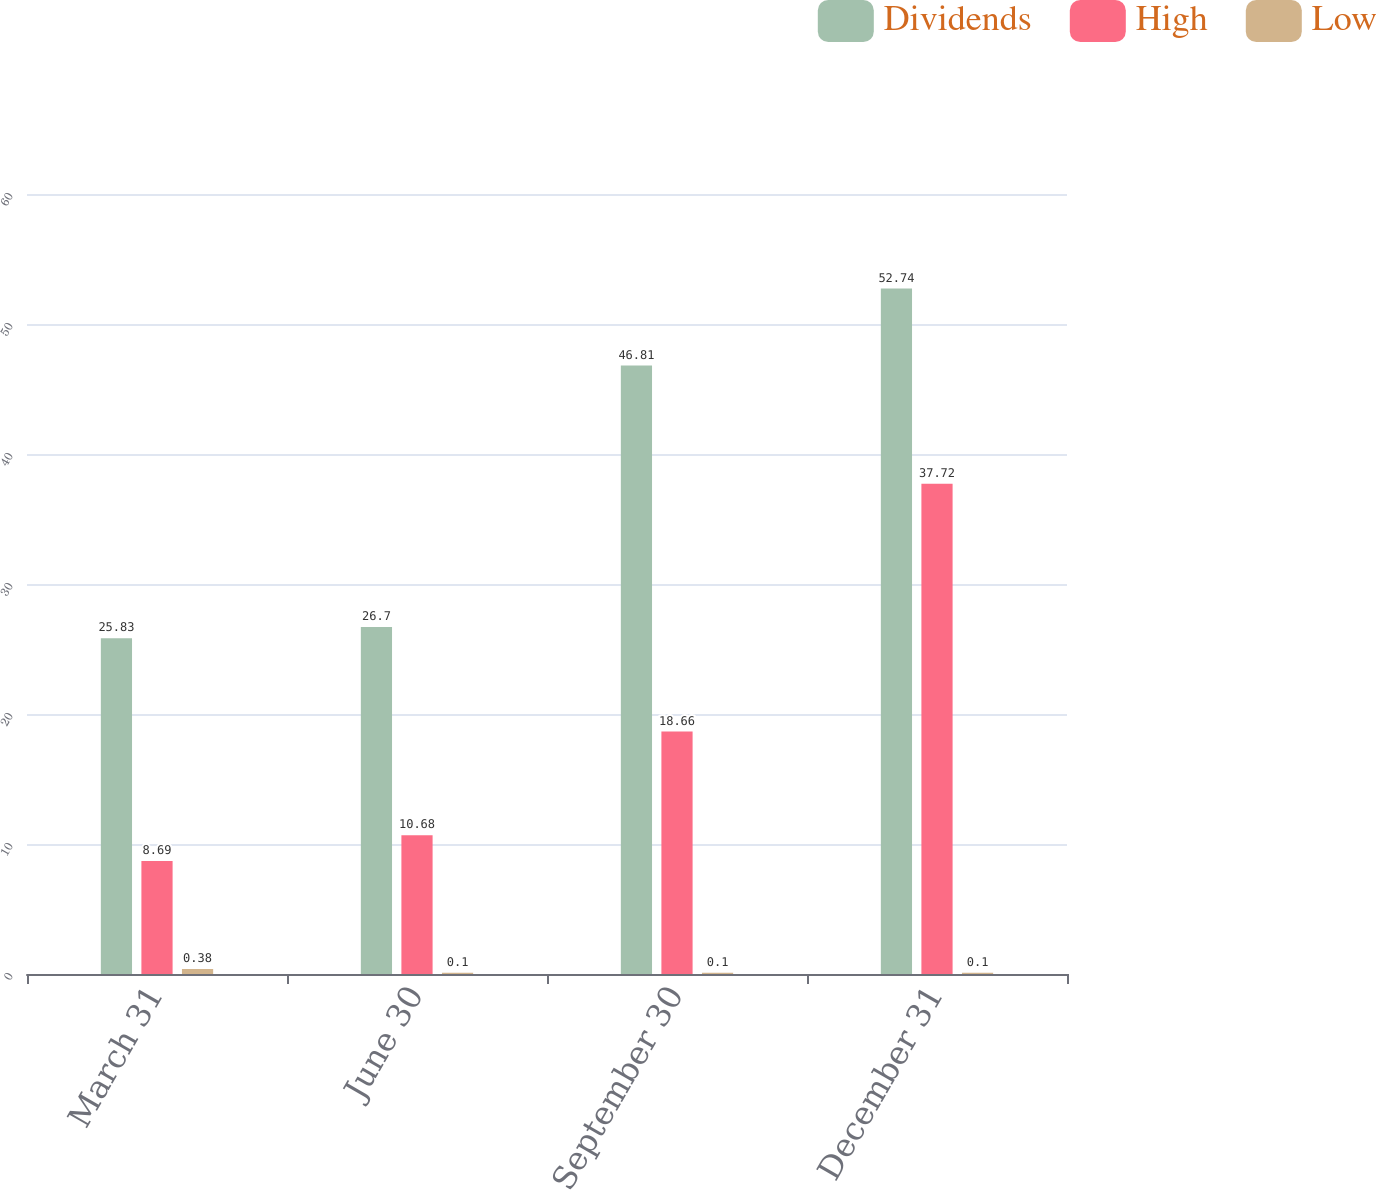<chart> <loc_0><loc_0><loc_500><loc_500><stacked_bar_chart><ecel><fcel>March 31<fcel>June 30<fcel>September 30<fcel>December 31<nl><fcel>Dividends<fcel>25.83<fcel>26.7<fcel>46.81<fcel>52.74<nl><fcel>High<fcel>8.69<fcel>10.68<fcel>18.66<fcel>37.72<nl><fcel>Low<fcel>0.38<fcel>0.1<fcel>0.1<fcel>0.1<nl></chart> 